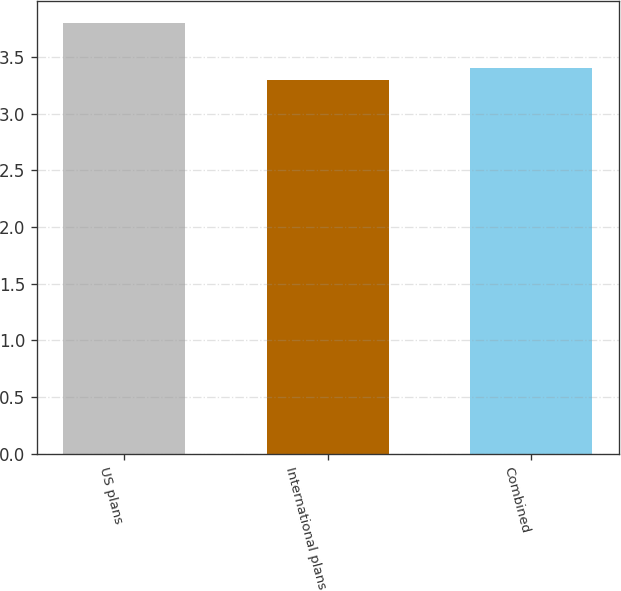Convert chart to OTSL. <chart><loc_0><loc_0><loc_500><loc_500><bar_chart><fcel>US plans<fcel>International plans<fcel>Combined<nl><fcel>3.8<fcel>3.3<fcel>3.4<nl></chart> 